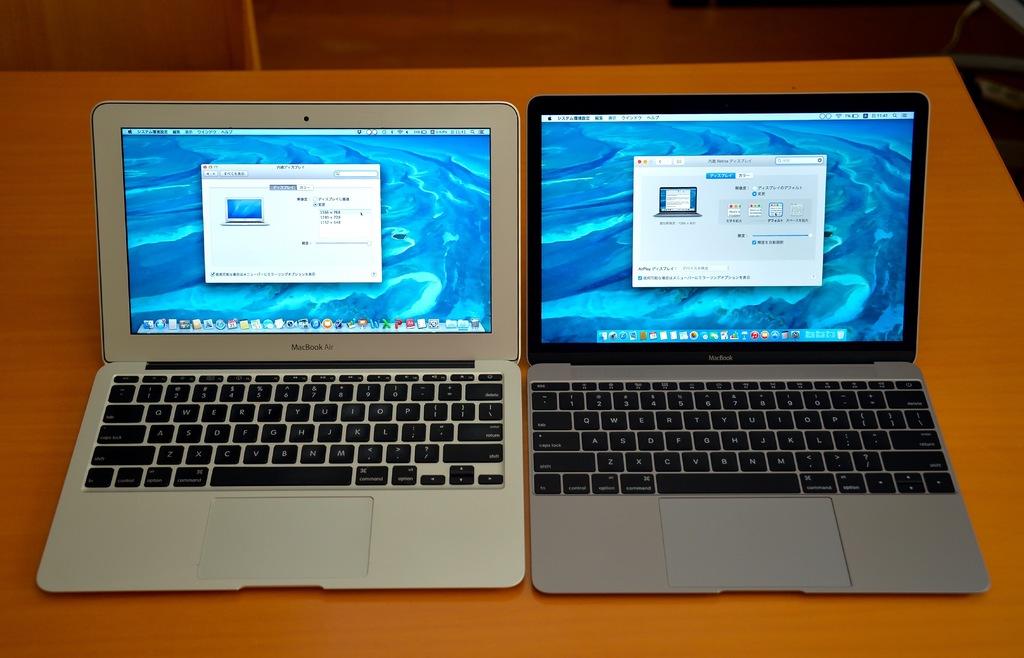What type of brand is the laptop?
Give a very brief answer. Macbook. 